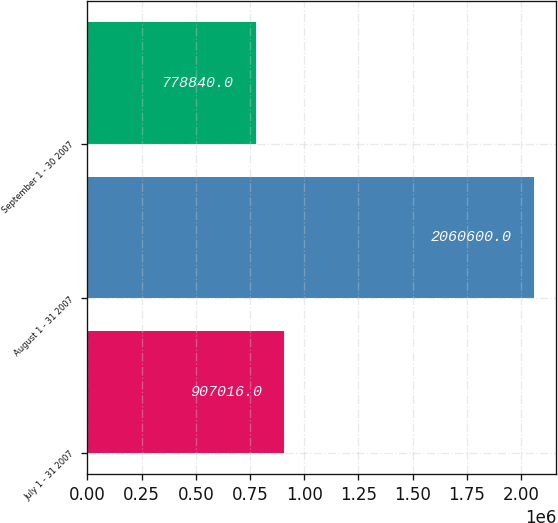Convert chart. <chart><loc_0><loc_0><loc_500><loc_500><bar_chart><fcel>July 1 - 31 2007<fcel>August 1 - 31 2007<fcel>September 1 - 30 2007<nl><fcel>907016<fcel>2.0606e+06<fcel>778840<nl></chart> 